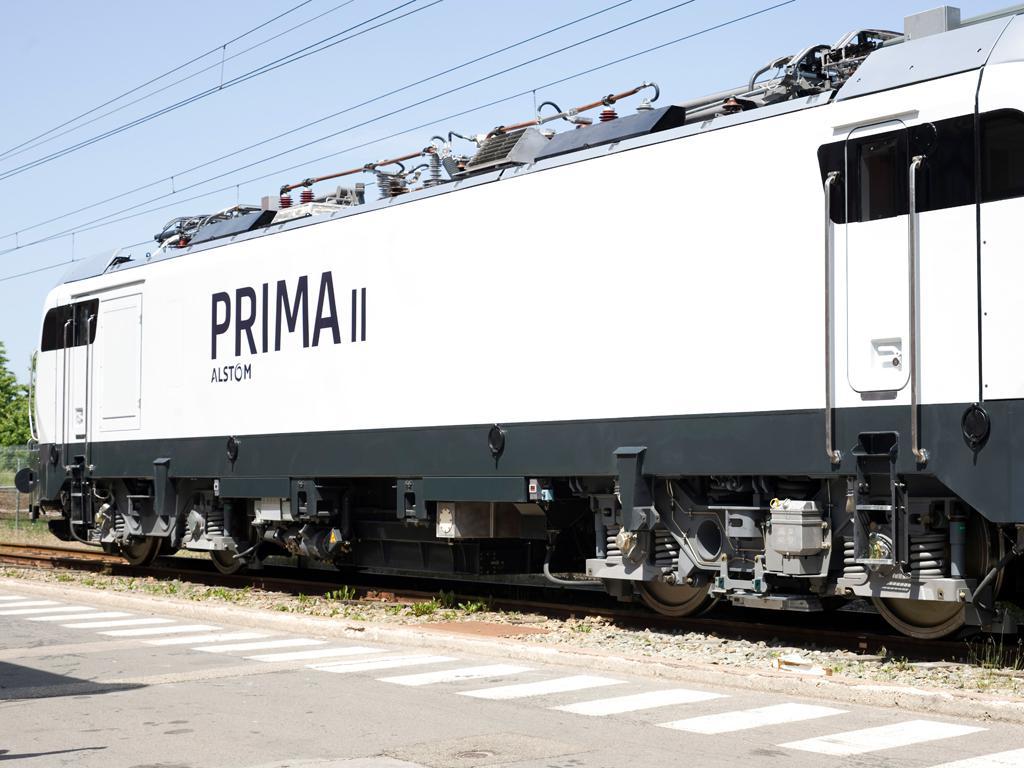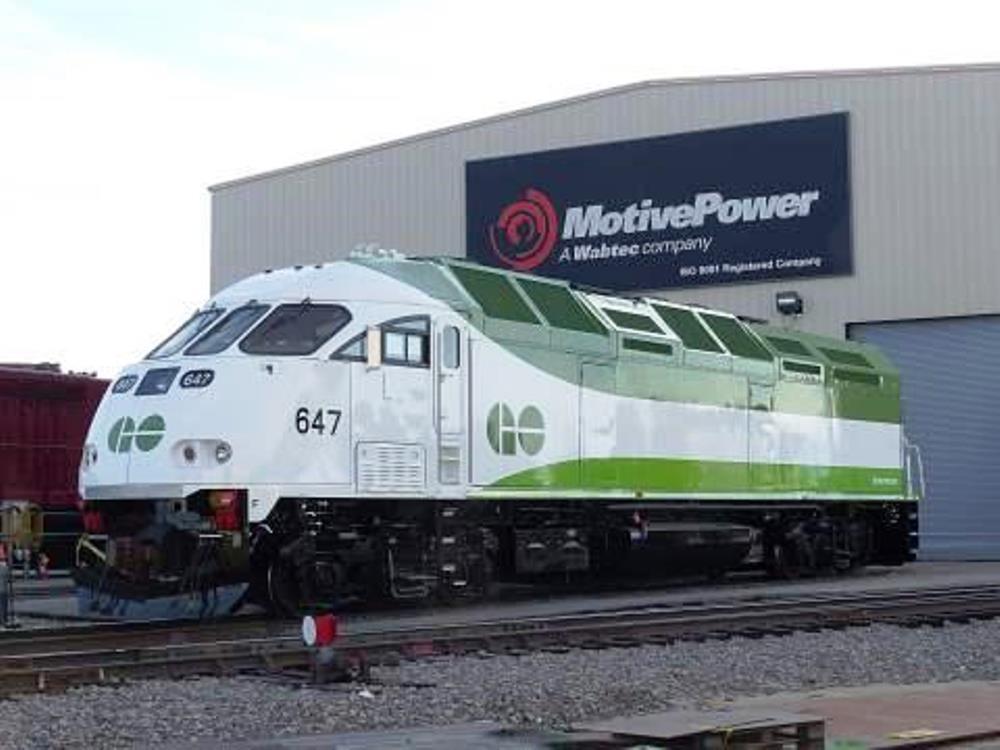The first image is the image on the left, the second image is the image on the right. Analyze the images presented: Is the assertion "One of the trains features the colors red, white, and blue with a blue stripe running the entire length of the car." valid? Answer yes or no. No. 